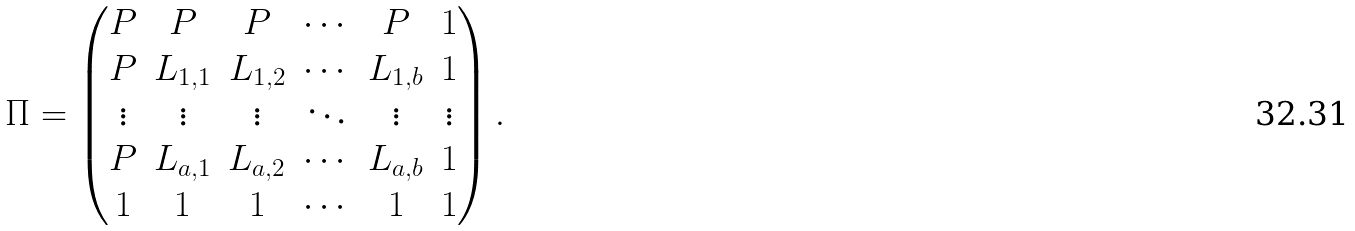Convert formula to latex. <formula><loc_0><loc_0><loc_500><loc_500>\Pi = \begin{pmatrix} P & P & P & \cdots & P & 1 \\ P & L _ { 1 , 1 } & L _ { 1 , 2 } & \cdots & L _ { 1 , b } & 1 \\ \vdots & \vdots & \vdots & \ddots & \vdots & \vdots \\ P & L _ { a , 1 } & L _ { a , 2 } & \cdots & L _ { a , b } & 1 \\ 1 & 1 & 1 & \cdots & 1 & 1 \end{pmatrix} .</formula> 